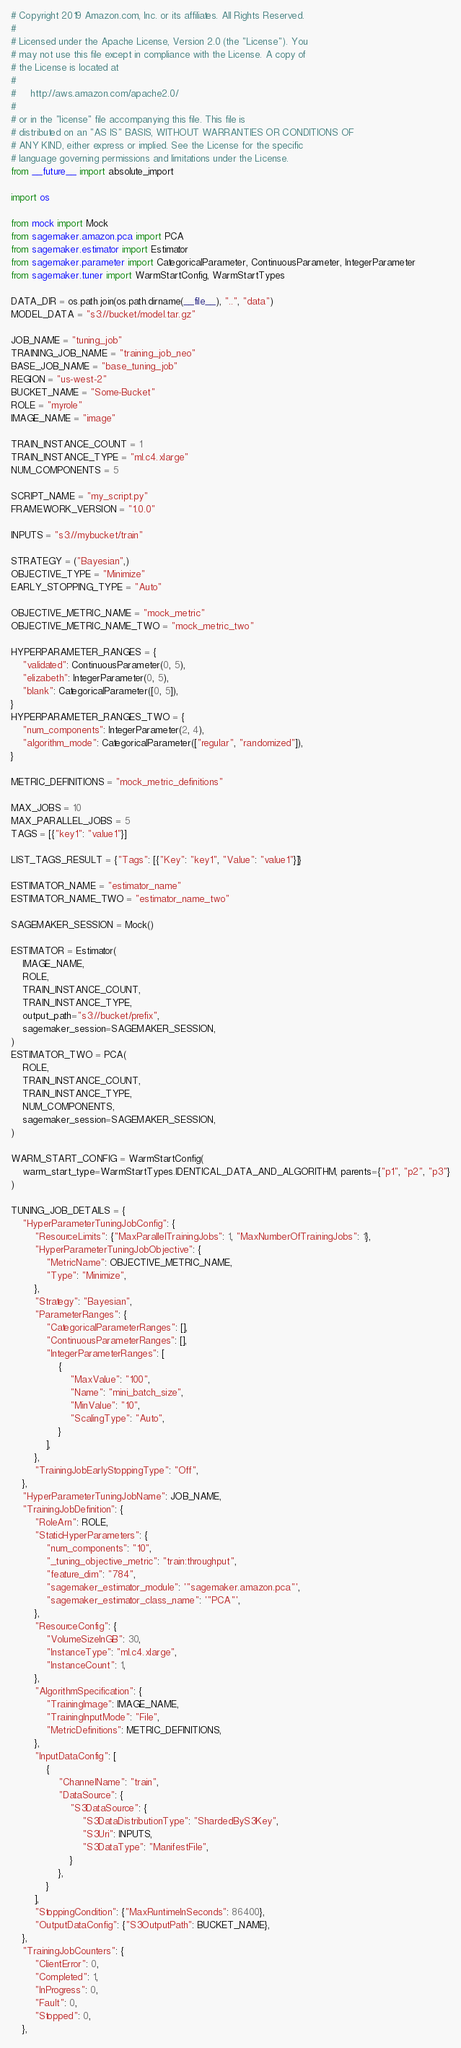<code> <loc_0><loc_0><loc_500><loc_500><_Python_># Copyright 2019 Amazon.com, Inc. or its affiliates. All Rights Reserved.
#
# Licensed under the Apache License, Version 2.0 (the "License"). You
# may not use this file except in compliance with the License. A copy of
# the License is located at
#
#     http://aws.amazon.com/apache2.0/
#
# or in the "license" file accompanying this file. This file is
# distributed on an "AS IS" BASIS, WITHOUT WARRANTIES OR CONDITIONS OF
# ANY KIND, either express or implied. See the License for the specific
# language governing permissions and limitations under the License.
from __future__ import absolute_import

import os

from mock import Mock
from sagemaker.amazon.pca import PCA
from sagemaker.estimator import Estimator
from sagemaker.parameter import CategoricalParameter, ContinuousParameter, IntegerParameter
from sagemaker.tuner import WarmStartConfig, WarmStartTypes

DATA_DIR = os.path.join(os.path.dirname(__file__), "..", "data")
MODEL_DATA = "s3://bucket/model.tar.gz"

JOB_NAME = "tuning_job"
TRAINING_JOB_NAME = "training_job_neo"
BASE_JOB_NAME = "base_tuning_job"
REGION = "us-west-2"
BUCKET_NAME = "Some-Bucket"
ROLE = "myrole"
IMAGE_NAME = "image"

TRAIN_INSTANCE_COUNT = 1
TRAIN_INSTANCE_TYPE = "ml.c4.xlarge"
NUM_COMPONENTS = 5

SCRIPT_NAME = "my_script.py"
FRAMEWORK_VERSION = "1.0.0"

INPUTS = "s3://mybucket/train"

STRATEGY = ("Bayesian",)
OBJECTIVE_TYPE = "Minimize"
EARLY_STOPPING_TYPE = "Auto"

OBJECTIVE_METRIC_NAME = "mock_metric"
OBJECTIVE_METRIC_NAME_TWO = "mock_metric_two"

HYPERPARAMETER_RANGES = {
    "validated": ContinuousParameter(0, 5),
    "elizabeth": IntegerParameter(0, 5),
    "blank": CategoricalParameter([0, 5]),
}
HYPERPARAMETER_RANGES_TWO = {
    "num_components": IntegerParameter(2, 4),
    "algorithm_mode": CategoricalParameter(["regular", "randomized"]),
}

METRIC_DEFINITIONS = "mock_metric_definitions"

MAX_JOBS = 10
MAX_PARALLEL_JOBS = 5
TAGS = [{"key1": "value1"}]

LIST_TAGS_RESULT = {"Tags": [{"Key": "key1", "Value": "value1"}]}

ESTIMATOR_NAME = "estimator_name"
ESTIMATOR_NAME_TWO = "estimator_name_two"

SAGEMAKER_SESSION = Mock()

ESTIMATOR = Estimator(
    IMAGE_NAME,
    ROLE,
    TRAIN_INSTANCE_COUNT,
    TRAIN_INSTANCE_TYPE,
    output_path="s3://bucket/prefix",
    sagemaker_session=SAGEMAKER_SESSION,
)
ESTIMATOR_TWO = PCA(
    ROLE,
    TRAIN_INSTANCE_COUNT,
    TRAIN_INSTANCE_TYPE,
    NUM_COMPONENTS,
    sagemaker_session=SAGEMAKER_SESSION,
)

WARM_START_CONFIG = WarmStartConfig(
    warm_start_type=WarmStartTypes.IDENTICAL_DATA_AND_ALGORITHM, parents={"p1", "p2", "p3"}
)

TUNING_JOB_DETAILS = {
    "HyperParameterTuningJobConfig": {
        "ResourceLimits": {"MaxParallelTrainingJobs": 1, "MaxNumberOfTrainingJobs": 1},
        "HyperParameterTuningJobObjective": {
            "MetricName": OBJECTIVE_METRIC_NAME,
            "Type": "Minimize",
        },
        "Strategy": "Bayesian",
        "ParameterRanges": {
            "CategoricalParameterRanges": [],
            "ContinuousParameterRanges": [],
            "IntegerParameterRanges": [
                {
                    "MaxValue": "100",
                    "Name": "mini_batch_size",
                    "MinValue": "10",
                    "ScalingType": "Auto",
                }
            ],
        },
        "TrainingJobEarlyStoppingType": "Off",
    },
    "HyperParameterTuningJobName": JOB_NAME,
    "TrainingJobDefinition": {
        "RoleArn": ROLE,
        "StaticHyperParameters": {
            "num_components": "10",
            "_tuning_objective_metric": "train:throughput",
            "feature_dim": "784",
            "sagemaker_estimator_module": '"sagemaker.amazon.pca"',
            "sagemaker_estimator_class_name": '"PCA"',
        },
        "ResourceConfig": {
            "VolumeSizeInGB": 30,
            "InstanceType": "ml.c4.xlarge",
            "InstanceCount": 1,
        },
        "AlgorithmSpecification": {
            "TrainingImage": IMAGE_NAME,
            "TrainingInputMode": "File",
            "MetricDefinitions": METRIC_DEFINITIONS,
        },
        "InputDataConfig": [
            {
                "ChannelName": "train",
                "DataSource": {
                    "S3DataSource": {
                        "S3DataDistributionType": "ShardedByS3Key",
                        "S3Uri": INPUTS,
                        "S3DataType": "ManifestFile",
                    }
                },
            }
        ],
        "StoppingCondition": {"MaxRuntimeInSeconds": 86400},
        "OutputDataConfig": {"S3OutputPath": BUCKET_NAME},
    },
    "TrainingJobCounters": {
        "ClientError": 0,
        "Completed": 1,
        "InProgress": 0,
        "Fault": 0,
        "Stopped": 0,
    },</code> 